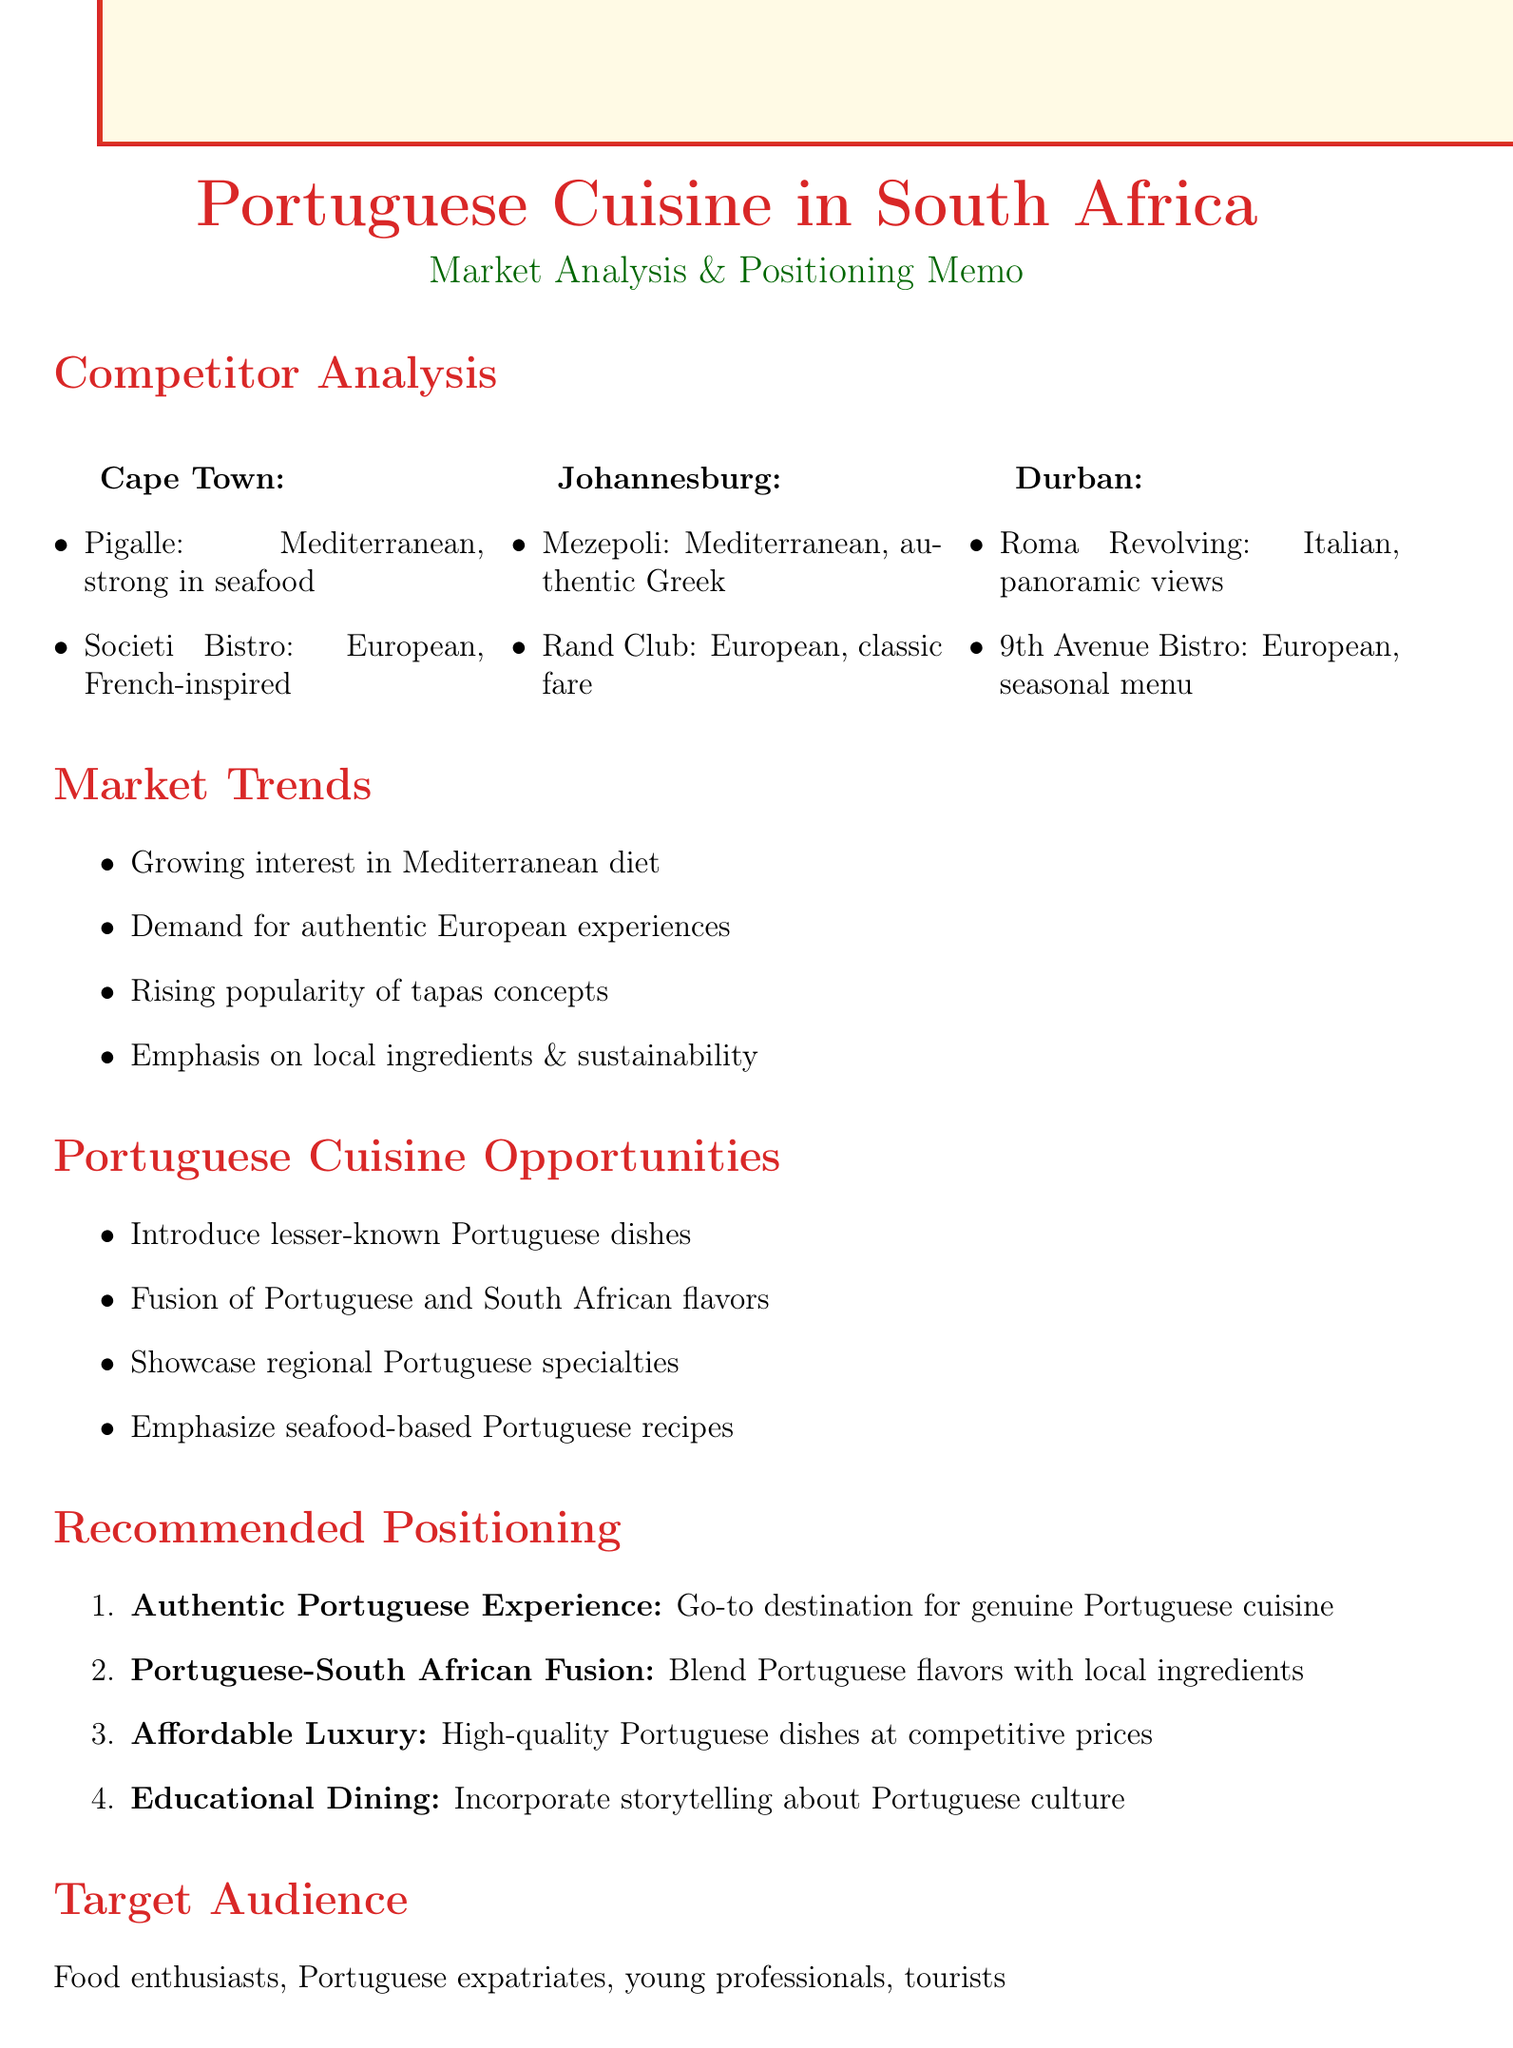What are the strengths of Pigalle? The strengths of Pigalle listed in the document are seafood specialties and upscale ambiance.
Answer: Seafood specialties, upscale ambiance Which city has restaurants serving Italian cuisine? The document mentions Roma Revolving Restaurant in Durban, which serves Italian cuisine.
Answer: Durban What is the recommended strategy for blending cuisines? The strategy mentioned is Portuguese-South African Fusion, which highlights blending Portuguese flavors with local ingredients.
Answer: Portuguese-South African Fusion List one market trend related to Mediterranean cuisine. One of the market trends is the growing interest in the Mediterranean diet and health benefits.
Answer: Growing interest in Mediterranean diet Who is part of the target audience for the restaurant? One group identified as part of the target audience is food enthusiasts seeking authentic European experiences.
Answer: Food enthusiasts seeking authentic European experiences What is a weakness of Mezepoli? The document states that inconsistent service is a weakness of Mezepoli.
Answer: Inconsistent service What type of dining experience does the document suggest incorporating storytelling? The document suggests an Educational Dining experience that incorporates storytelling about Portuguese culture.
Answer: Educational Dining What is a challenge related to sourcing ingredients? The document notes sourcing authentic Portuguese ingredients in South Africa as a challenge.
Answer: Sourcing authentic Portuguese ingredients in South Africa 